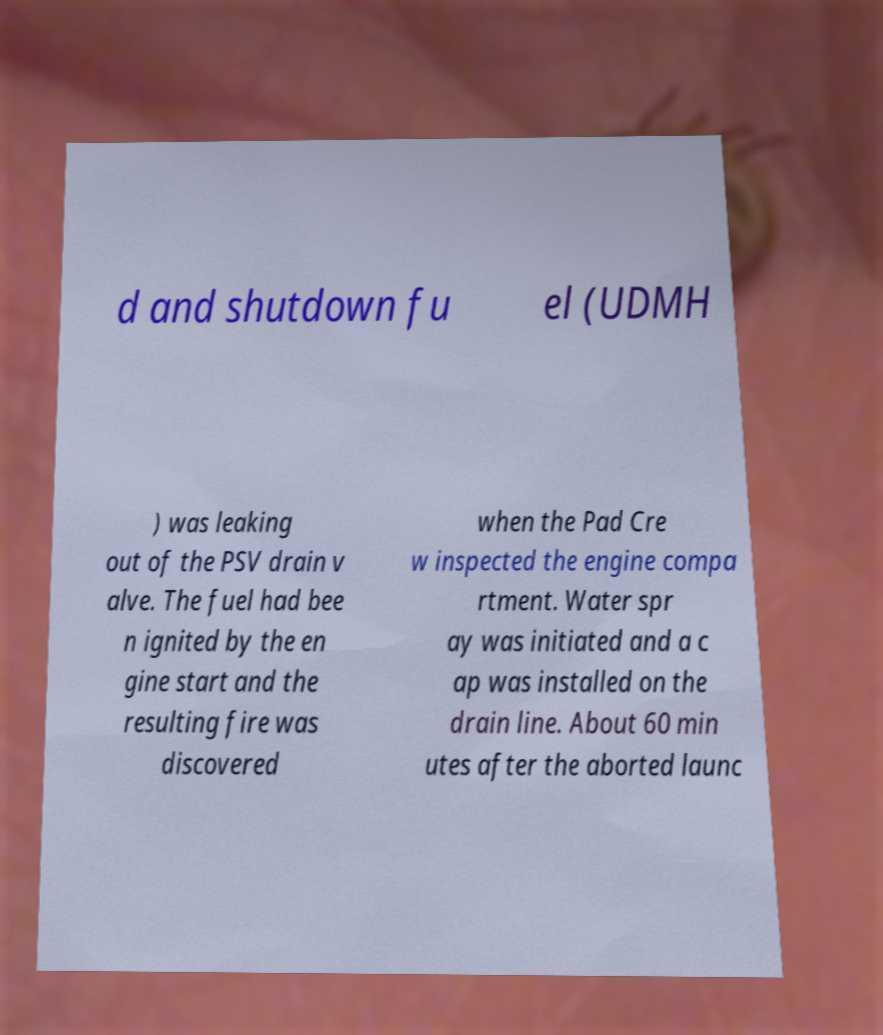There's text embedded in this image that I need extracted. Can you transcribe it verbatim? d and shutdown fu el (UDMH ) was leaking out of the PSV drain v alve. The fuel had bee n ignited by the en gine start and the resulting fire was discovered when the Pad Cre w inspected the engine compa rtment. Water spr ay was initiated and a c ap was installed on the drain line. About 60 min utes after the aborted launc 